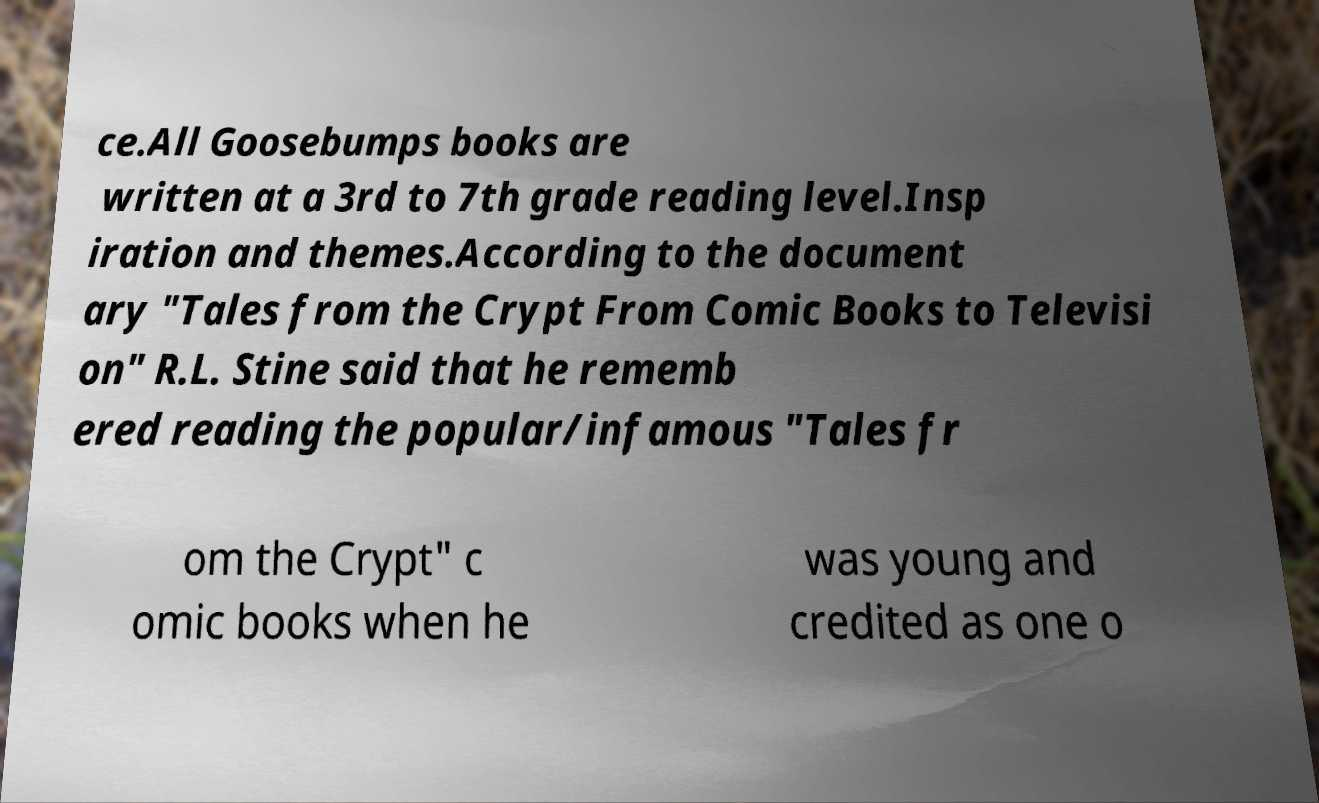For documentation purposes, I need the text within this image transcribed. Could you provide that? ce.All Goosebumps books are written at a 3rd to 7th grade reading level.Insp iration and themes.According to the document ary "Tales from the Crypt From Comic Books to Televisi on" R.L. Stine said that he rememb ered reading the popular/infamous "Tales fr om the Crypt" c omic books when he was young and credited as one o 